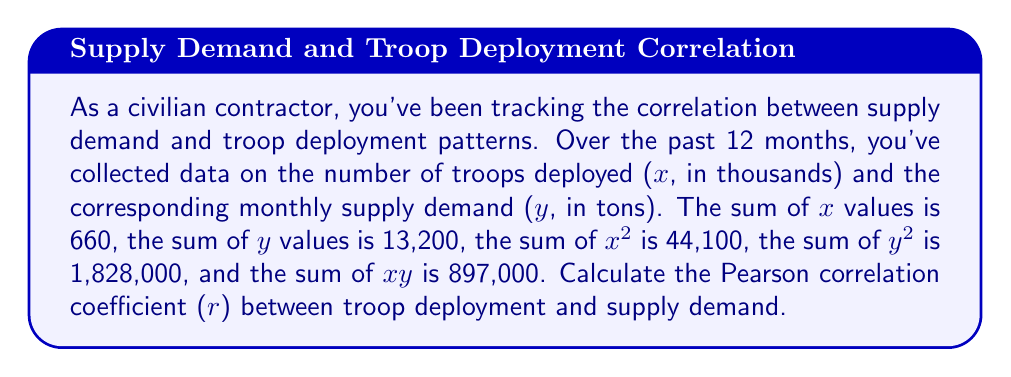What is the answer to this math problem? To calculate the Pearson correlation coefficient (r), we'll use the formula:

$$ r = \frac{n\sum xy - \sum x \sum y}{\sqrt{[n\sum x^2 - (\sum x)^2][n\sum y^2 - (\sum y)^2]}} $$

Where n is the number of data points (12 months in this case).

Given:
n = 12
$\sum x = 660$
$\sum y = 13,200$
$\sum x^2 = 44,100$
$\sum y^2 = 1,828,000$
$\sum xy = 897,000$

Step 1: Calculate $n\sum xy$
$12 \times 897,000 = 10,764,000$

Step 2: Calculate $\sum x \sum y$
$660 \times 13,200 = 8,712,000$

Step 3: Calculate the numerator
$10,764,000 - 8,712,000 = 2,052,000$

Step 4: Calculate $n\sum x^2$
$12 \times 44,100 = 529,200$

Step 5: Calculate $(\sum x)^2$
$660^2 = 435,600$

Step 6: Calculate $n\sum y^2$
$12 \times 1,828,000 = 21,936,000$

Step 7: Calculate $(\sum y)^2$
$13,200^2 = 174,240,000$

Step 8: Calculate the denominator
$\sqrt{[529,200 - 435,600][21,936,000 - 174,240,000]}$
$= \sqrt{93,600 \times 47,696,000}$
$= \sqrt{4,464,345,600,000}$
$= 2,112,900$

Step 9: Calculate r
$r = \frac{2,052,000}{2,112,900} \approx 0.9713$
Answer: $r \approx 0.9713$ 